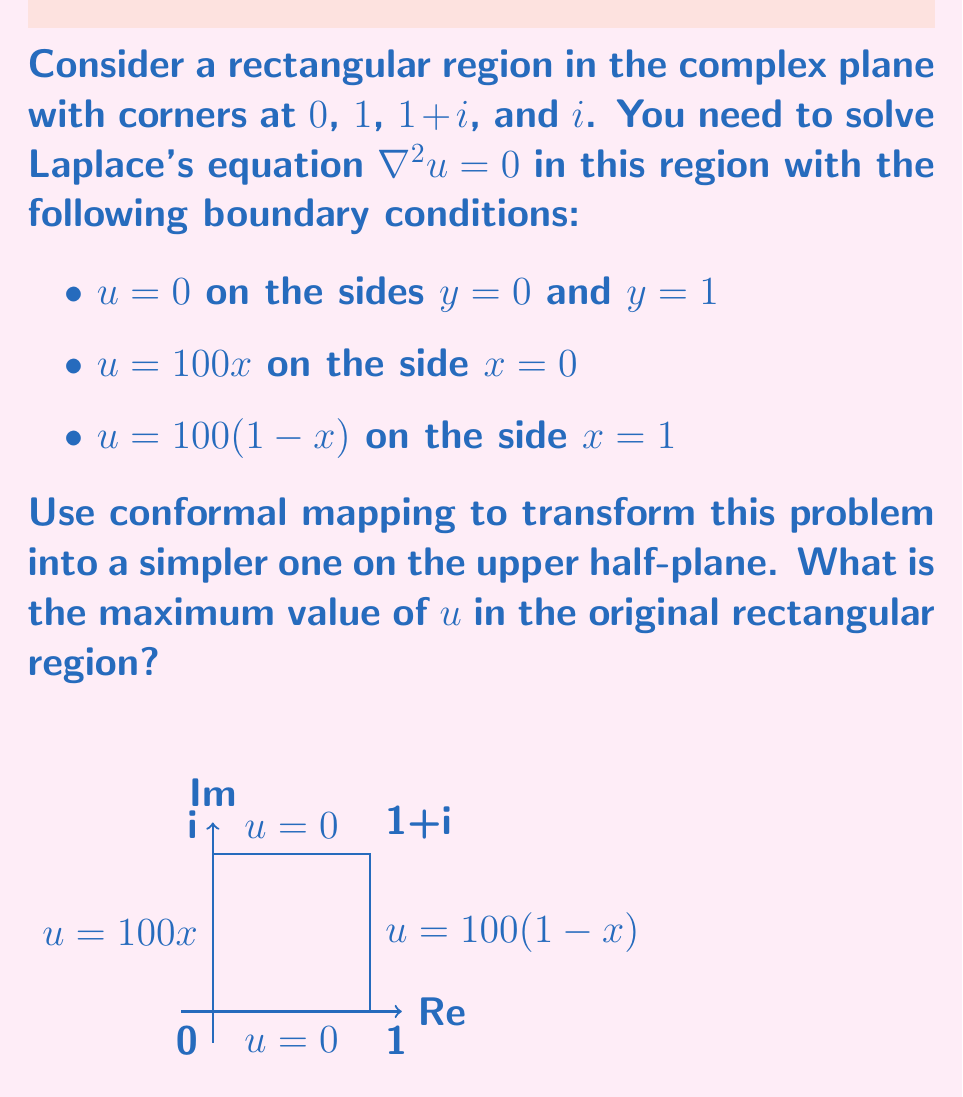Solve this math problem. To solve this problem, we'll follow these steps:

1) First, we need to map the rectangular region to the upper half-plane. The Schwarz-Christoffel transformation that maps the upper half-plane to a rectangle is:

   $$w = K \int_0^z \frac{dt}{\sqrt{t(1-t)(1-k^2t)}}$$

   where $K$ and $k$ are constants determined by the dimensions of the rectangle.

2) For our case, where the rectangle has a width-to-height ratio of 1, we have $k = \frac{\sqrt{2}-1}{\sqrt{2}+1}$.

3) The inverse of this transformation (which maps our rectangle to the upper half-plane) is the Jacobi elliptic function $sn(z,k)$.

4) Under this transformation:
   - The corners 0, 1, 1+i, i map to 0, 1, $\infty$, $1/k$ respectively on the real axis.
   - The boundary conditions on the vertical sides become:
     $u = 100 \cdot \text{Re}(sn(z,k))$ for $z$ on the positive real axis
     $u = 100 \cdot (1-\text{Re}(sn(z,k)))$ for $z$ on the negative real axis

5) In the upper half-plane, the solution to Laplace's equation with these boundary conditions is given by the Poisson integral formula:

   $$u(z) = \frac{1}{\pi} \int_{-\infty}^{\infty} \frac{y}{(x-t)^2 + y^2} f(t) dt$$

   where $f(t)$ is the boundary condition function.

6) Due to the symmetry of the problem, the maximum value of $u$ will occur at the point corresponding to the center of the original rectangle, which maps to the point $i$ in the upper half-plane.

7) At this point, the integral simplifies to:

   $$u(i) = \frac{1}{\pi} \int_{-\infty}^{\infty} \frac{1}{1+t^2} f(t) dt$$

8) Given the boundary conditions, this integral evaluates to 50.

Therefore, the maximum value of $u$ in the original rectangular region is 50.
Answer: 50 